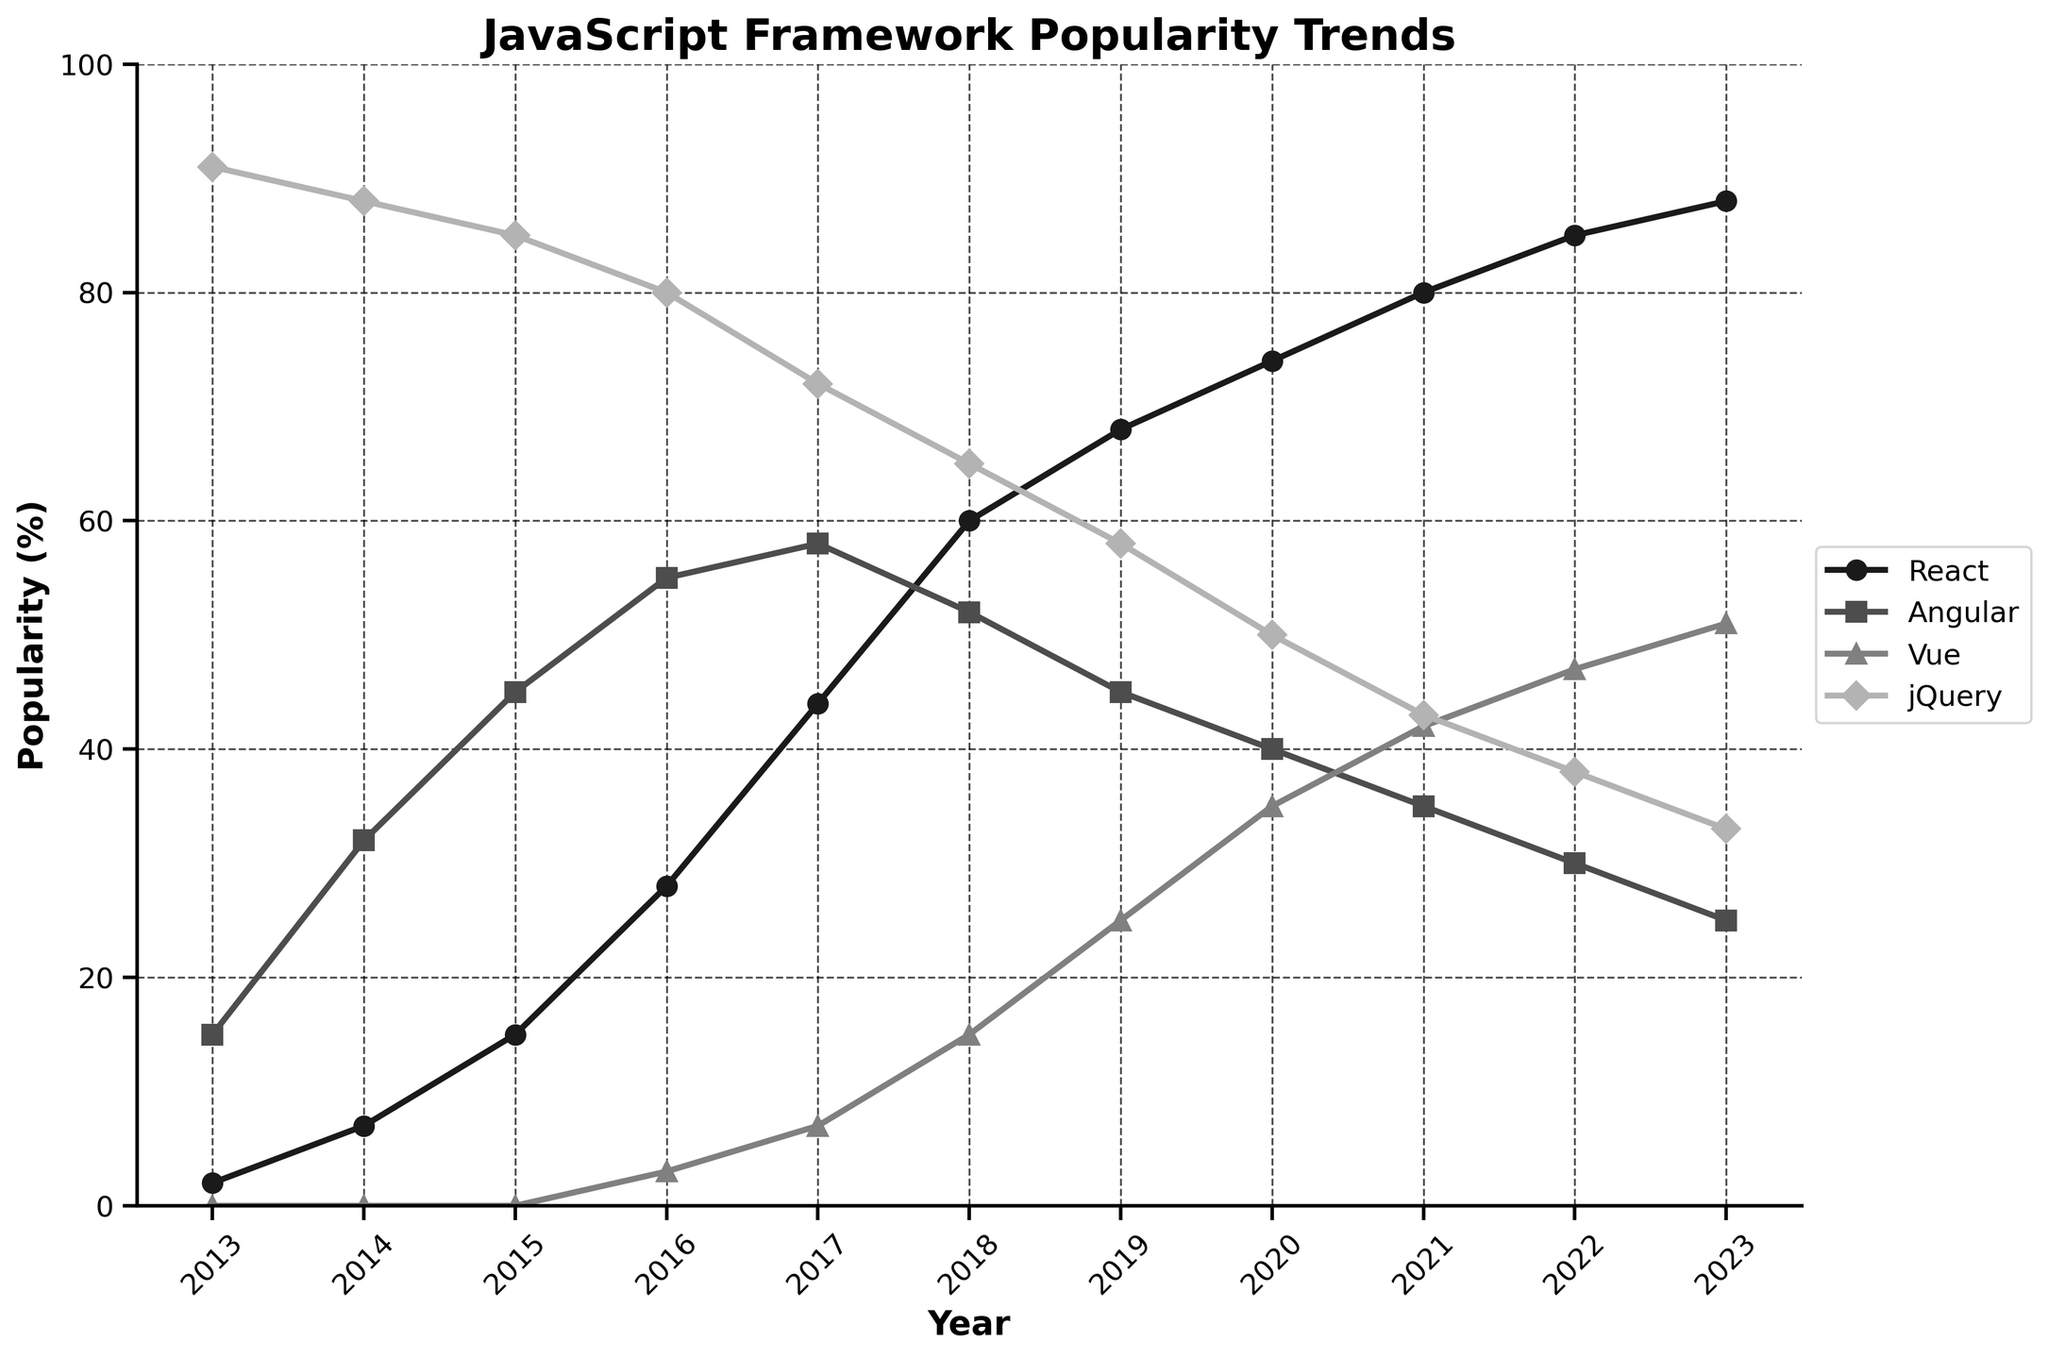What trend do you observe for React from 2013 to 2023? React's popularity increased continuously from 2% in 2013 to 88% in 2023.
Answer: Continuous increase In which year did Vue first appear in the chart, and what was its popularity percentage? Vue first appeared in 2016 with a popularity of 3%.
Answer: 2016, 3% How does jQuery's popularity in 2013 compare to its popularity in 2023? In 2013, jQuery's popularity was 91%, but it declined to 33% in 2023, showing a significant decrease.
Answer: Decrease Which framework had the highest popularity in 2017, and what was its percentage? Angular had the highest popularity in 2017 with a percentage of 58%.
Answer: Angular, 58% What is the difference in popularity between React and Angular in 2023? React had a popularity of 88%, and Angular had 25%. The difference is 88% - 25% = 63%.
Answer: 63% Between which years did Vue see the most significant increase in popularity? Vue saw the most significant increase between 2019 and 2020, from 25% to 35%, which is an increase of 10%.
Answer: 2019 to 2020 What is the average popularity of React over the decade from 2013 to 2023? Sum the popularity percentages for React from 2013 to 2023 (2 + 7 + 15 + 28 + 44 + 60 + 68 + 74 + 80 + 85 + 88) = 551. Divide by the number of years (11), so the average is 551 / 11 = 50.1%.
Answer: 50.1% How does the popularity gap between React and Vue change from 2016 to 2020? In 2016, the gap between React and Vue was 25% (28% - 3%). In 2020, the gap was 39% (74% - 35%). The gap increases by 39% - 25% = 14%.
Answer: Increased by 14% Which framework experienced the steepest decline over any consecutive years, and by how much? Angular experienced the steepest decline from 2018 to 2019, dropping from 52% to 45%, which is a decline of 7%.
Answer: Angular, 7% What are the popularity percentages of React and Vue in 2021, and how do they compare? In 2021, React had a popularity of 80%, and Vue had 42%. React's popularity was 38% higher than Vue's. 80% - 42% = 38%.
Answer: React 38% higher 